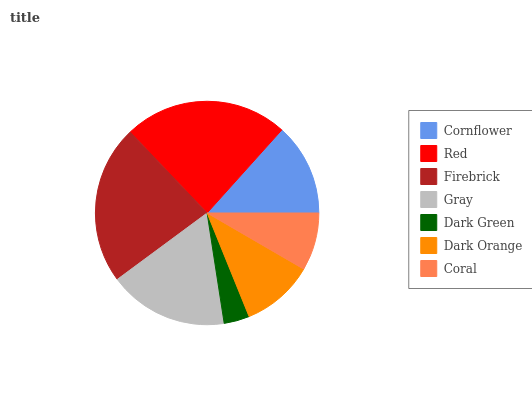Is Dark Green the minimum?
Answer yes or no. Yes. Is Red the maximum?
Answer yes or no. Yes. Is Firebrick the minimum?
Answer yes or no. No. Is Firebrick the maximum?
Answer yes or no. No. Is Red greater than Firebrick?
Answer yes or no. Yes. Is Firebrick less than Red?
Answer yes or no. Yes. Is Firebrick greater than Red?
Answer yes or no. No. Is Red less than Firebrick?
Answer yes or no. No. Is Cornflower the high median?
Answer yes or no. Yes. Is Cornflower the low median?
Answer yes or no. Yes. Is Gray the high median?
Answer yes or no. No. Is Coral the low median?
Answer yes or no. No. 